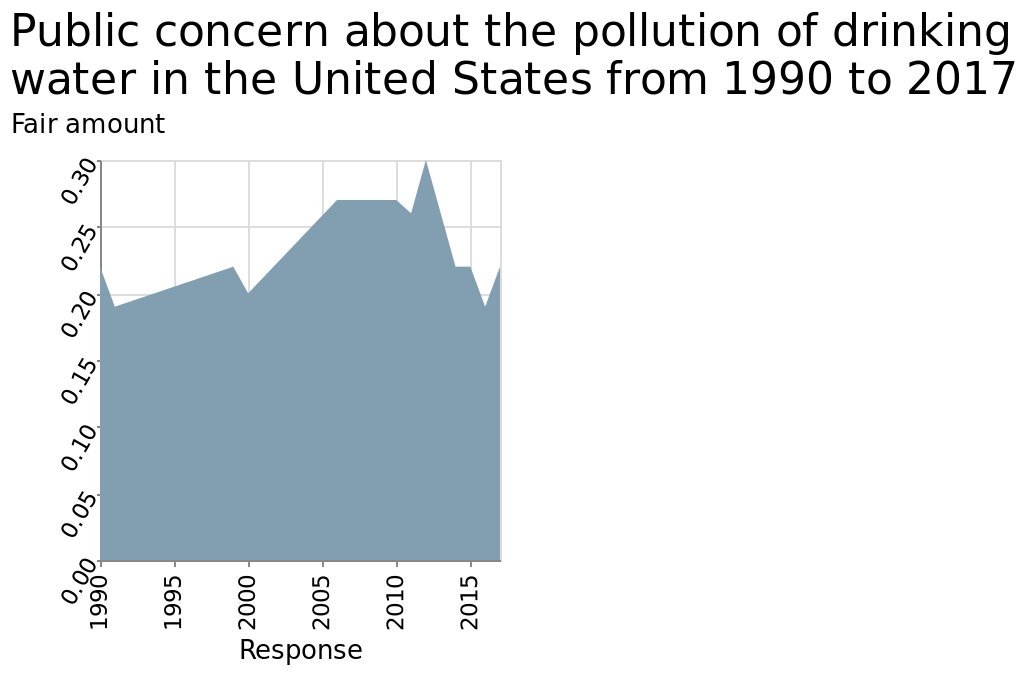<image>
What is the x-axis of the area chart?  The x-axis of the area chart represents the years from 1990 to 2015. Describe the trend in average concern between 1990 and 2012.  The average concern steadily rose during this period. Is there a clear definition of what "fair amount" means in this context? No, the description does not provide a specific quantification for the term "fair amount." Offer a thorough analysis of the image. average concern rose steadily between 1990 and 2012. Although it plateaued between 2006 & 2010From 2012 ir dropped sarply again back down to near 1990 levels. However i am unsure how to quantify what the value "fair amount" means. 